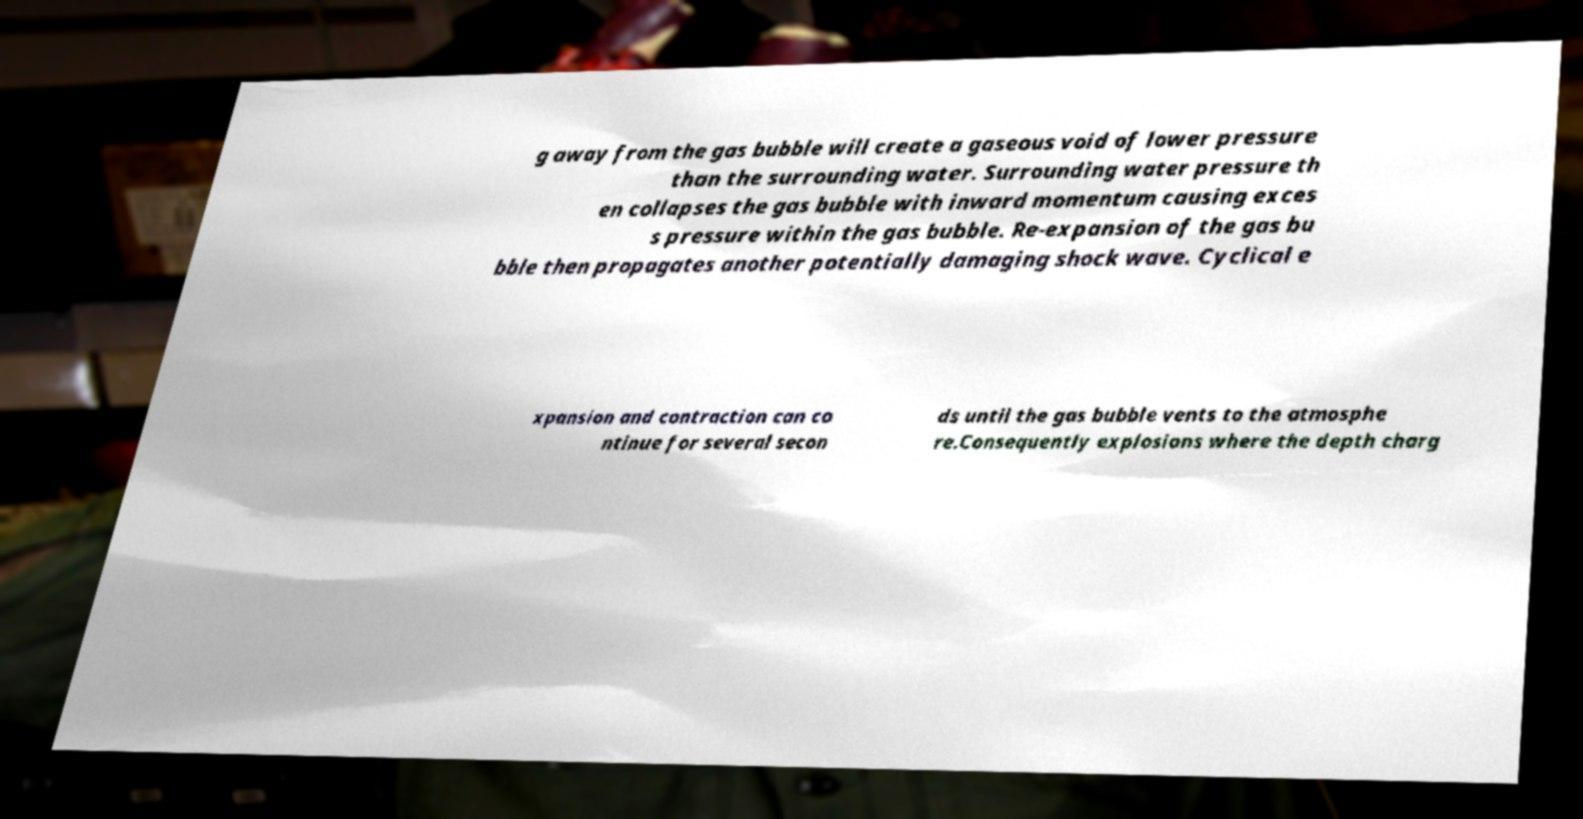For documentation purposes, I need the text within this image transcribed. Could you provide that? g away from the gas bubble will create a gaseous void of lower pressure than the surrounding water. Surrounding water pressure th en collapses the gas bubble with inward momentum causing exces s pressure within the gas bubble. Re-expansion of the gas bu bble then propagates another potentially damaging shock wave. Cyclical e xpansion and contraction can co ntinue for several secon ds until the gas bubble vents to the atmosphe re.Consequently explosions where the depth charg 